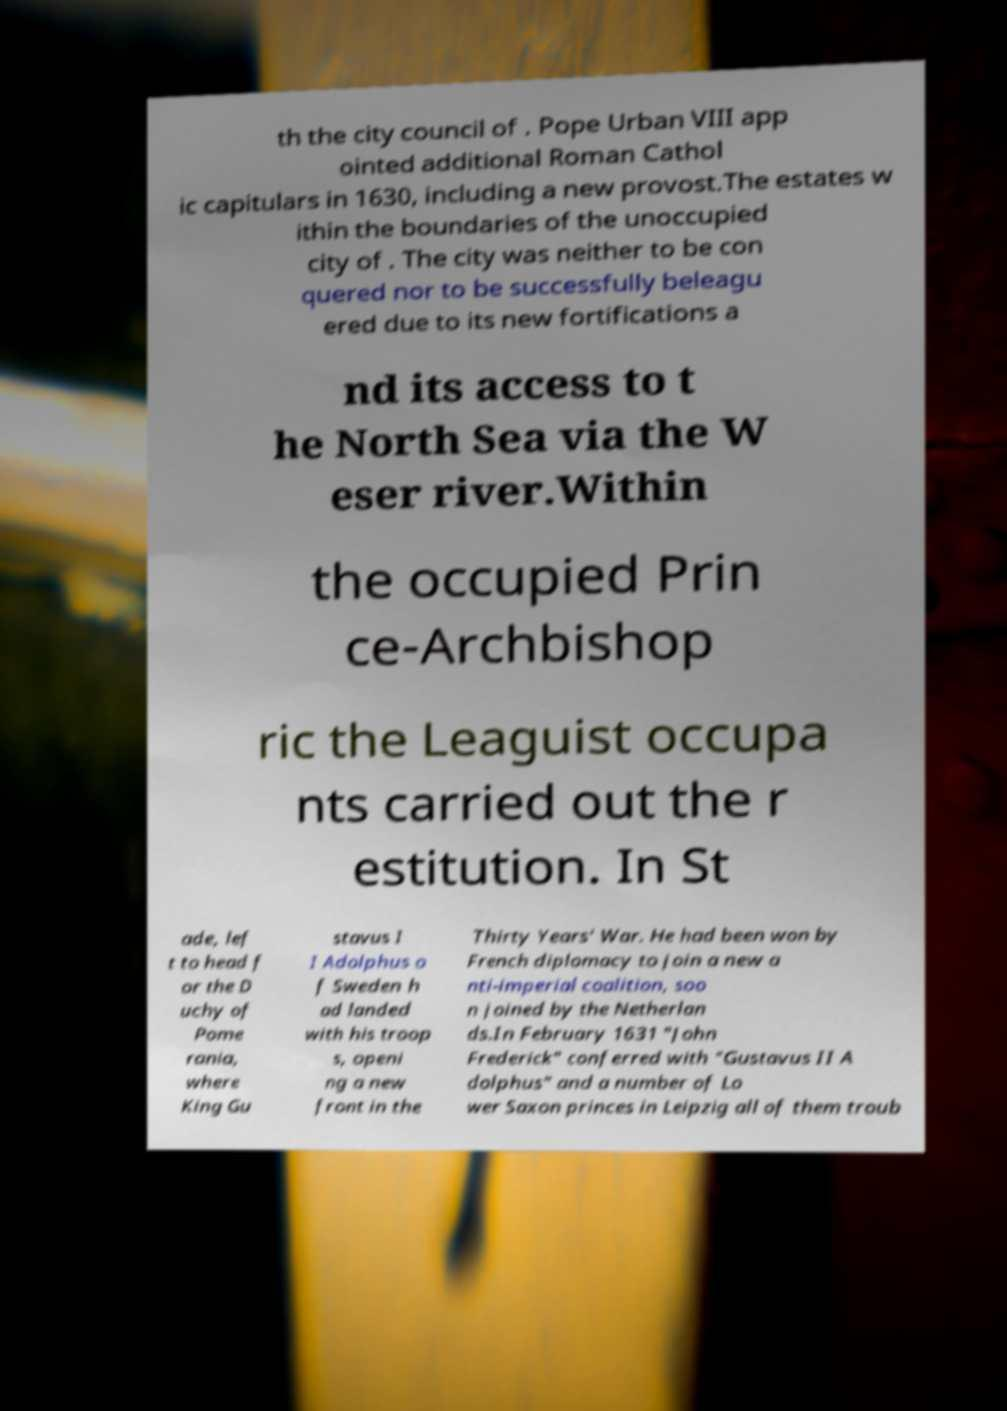For documentation purposes, I need the text within this image transcribed. Could you provide that? th the city council of . Pope Urban VIII app ointed additional Roman Cathol ic capitulars in 1630, including a new provost.The estates w ithin the boundaries of the unoccupied city of . The city was neither to be con quered nor to be successfully beleagu ered due to its new fortifications a nd its access to t he North Sea via the W eser river.Within the occupied Prin ce-Archbishop ric the Leaguist occupa nts carried out the r estitution. In St ade, lef t to head f or the D uchy of Pome rania, where King Gu stavus I I Adolphus o f Sweden h ad landed with his troop s, openi ng a new front in the Thirty Years' War. He had been won by French diplomacy to join a new a nti-imperial coalition, soo n joined by the Netherlan ds.In February 1631 "John Frederick" conferred with "Gustavus II A dolphus" and a number of Lo wer Saxon princes in Leipzig all of them troub 